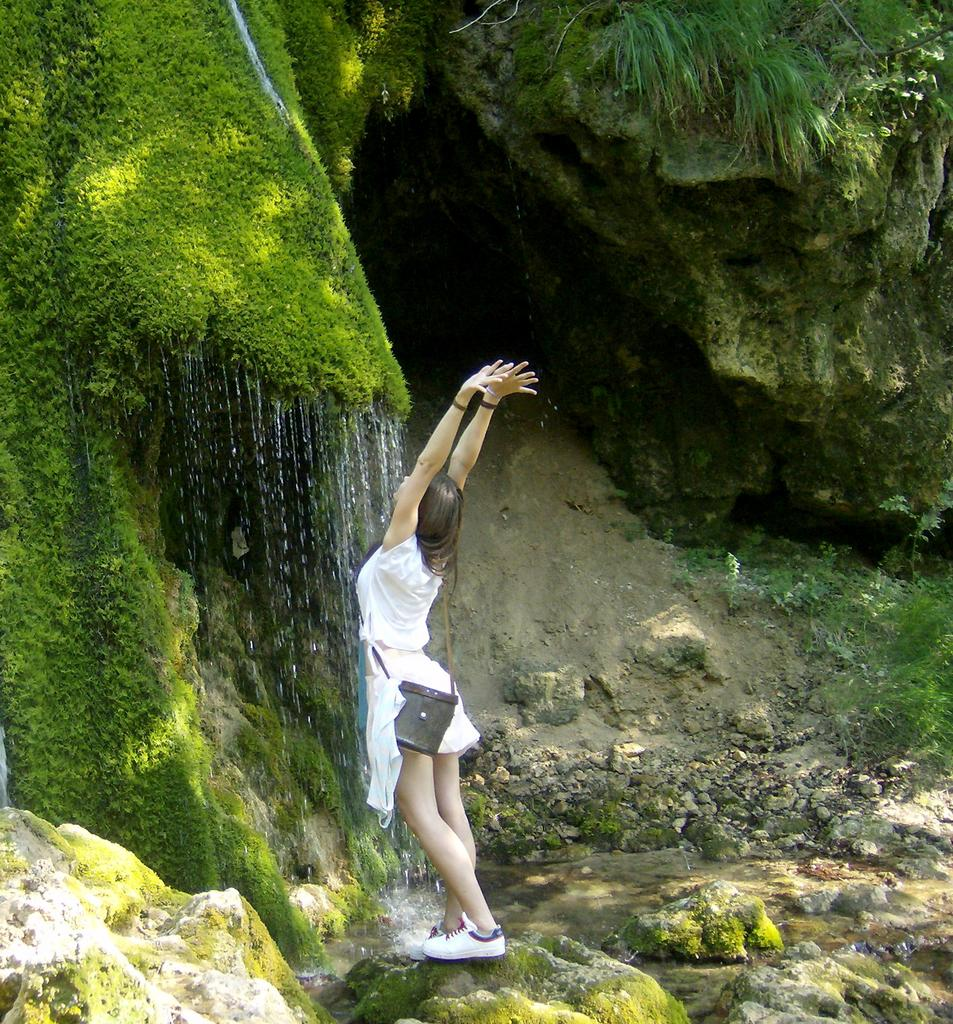Who is present in the image? There is a girl in the image. What is the girl holding or carrying? The girl is carrying a bag. What is the girl's posture in the image? The girl is standing. What type of terrain is visible in the image? There are rocks, grass, and water visible in the image. What is on the ground in the image? There are stones on the ground in the image. What type of writing can be seen on the dinosaur's neck in the image? There are no dinosaurs or writing present in the image. 